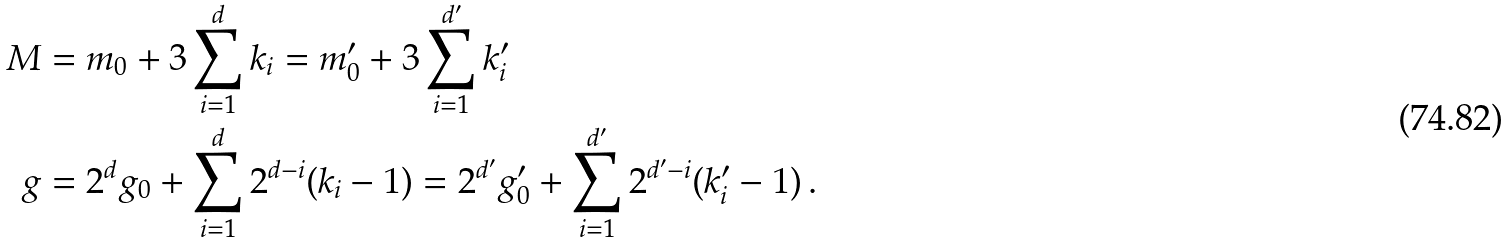Convert formula to latex. <formula><loc_0><loc_0><loc_500><loc_500>M & = m _ { 0 } + 3 \sum _ { i = 1 } ^ { d } k _ { i } = m ^ { \prime } _ { 0 } + 3 \sum _ { i = 1 } ^ { d ^ { \prime } } k ^ { \prime } _ { i } \, \\ g & = 2 ^ { d } g _ { 0 } + \sum _ { i = 1 } ^ { d } 2 ^ { d - i } ( k _ { i } - 1 ) = 2 ^ { d ^ { \prime } } g ^ { \prime } _ { 0 } + \sum _ { i = 1 } ^ { d ^ { \prime } } 2 ^ { d ^ { \prime } - i } ( k ^ { \prime } _ { i } - 1 ) \, .</formula> 